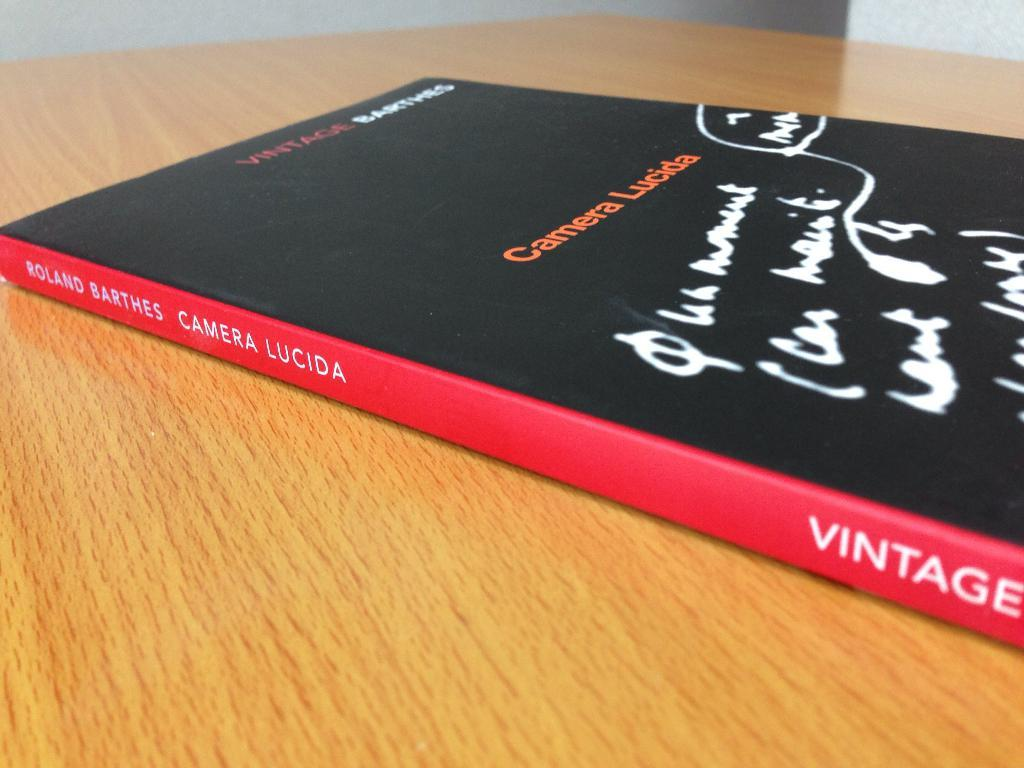<image>
Create a compact narrative representing the image presented. a book that has the word vintage on it 